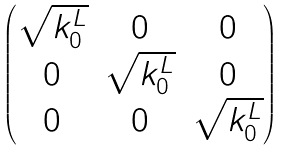Convert formula to latex. <formula><loc_0><loc_0><loc_500><loc_500>\begin{pmatrix} \sqrt { k _ { 0 } ^ { L } } & 0 & 0 \\ 0 & \sqrt { k _ { 0 } ^ { L } } & 0 \\ 0 & 0 & \sqrt { k _ { 0 } ^ { L } } \end{pmatrix}</formula> 